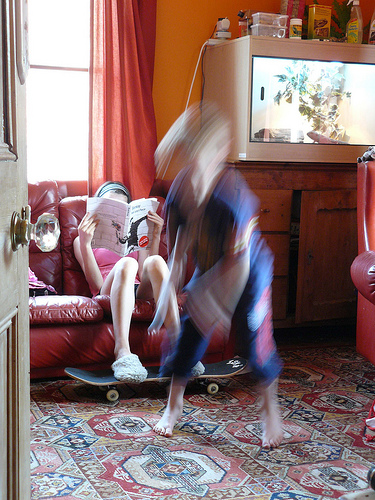<image>
Is there a book in front of the girl? Yes. The book is positioned in front of the girl, appearing closer to the camera viewpoint. 